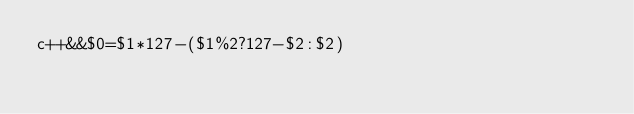<code> <loc_0><loc_0><loc_500><loc_500><_Awk_>c++&&$0=$1*127-($1%2?127-$2:$2)</code> 